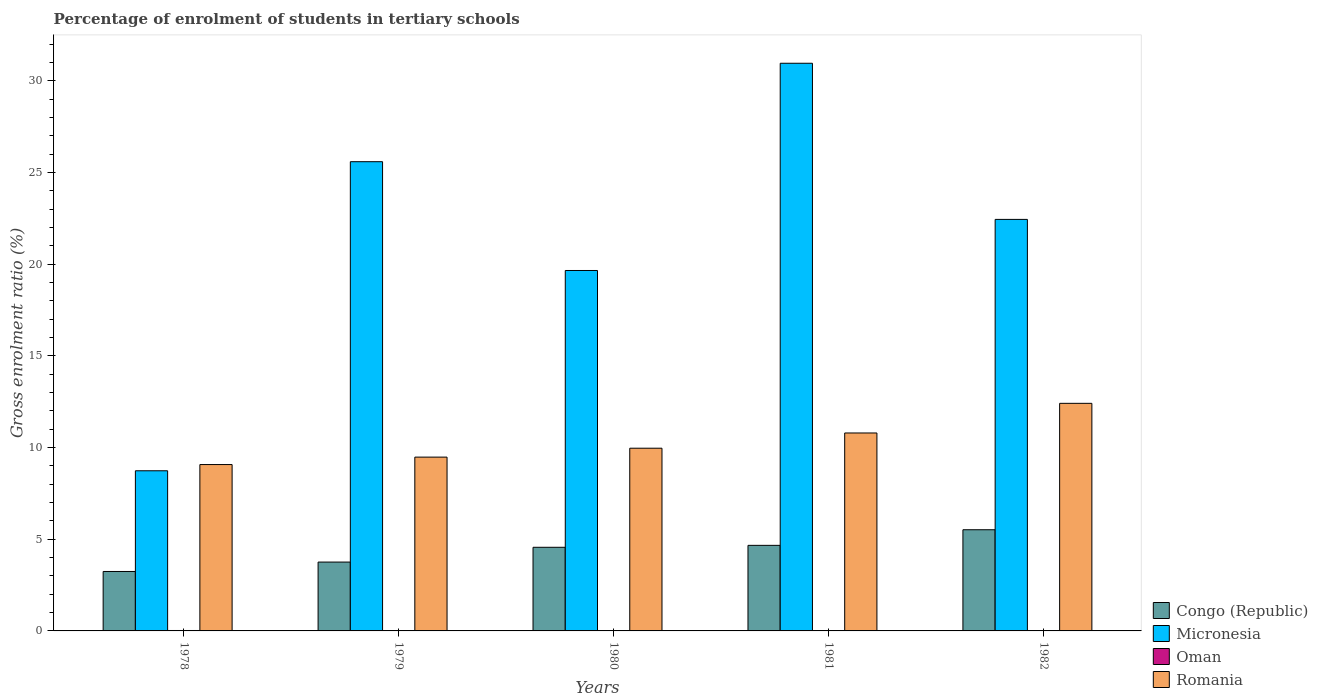Are the number of bars on each tick of the X-axis equal?
Offer a terse response. Yes. How many bars are there on the 3rd tick from the left?
Offer a terse response. 4. What is the label of the 5th group of bars from the left?
Ensure brevity in your answer.  1982. In how many cases, is the number of bars for a given year not equal to the number of legend labels?
Your response must be concise. 0. What is the percentage of students enrolled in tertiary schools in Romania in 1978?
Your answer should be compact. 9.07. Across all years, what is the maximum percentage of students enrolled in tertiary schools in Romania?
Make the answer very short. 12.41. Across all years, what is the minimum percentage of students enrolled in tertiary schools in Romania?
Keep it short and to the point. 9.07. In which year was the percentage of students enrolled in tertiary schools in Micronesia minimum?
Your response must be concise. 1978. What is the total percentage of students enrolled in tertiary schools in Romania in the graph?
Give a very brief answer. 51.73. What is the difference between the percentage of students enrolled in tertiary schools in Congo (Republic) in 1978 and that in 1982?
Give a very brief answer. -2.28. What is the difference between the percentage of students enrolled in tertiary schools in Micronesia in 1979 and the percentage of students enrolled in tertiary schools in Oman in 1980?
Make the answer very short. 25.58. What is the average percentage of students enrolled in tertiary schools in Congo (Republic) per year?
Offer a terse response. 4.35. In the year 1981, what is the difference between the percentage of students enrolled in tertiary schools in Oman and percentage of students enrolled in tertiary schools in Romania?
Your answer should be very brief. -10.78. What is the ratio of the percentage of students enrolled in tertiary schools in Romania in 1981 to that in 1982?
Offer a very short reply. 0.87. What is the difference between the highest and the second highest percentage of students enrolled in tertiary schools in Micronesia?
Make the answer very short. 5.37. What is the difference between the highest and the lowest percentage of students enrolled in tertiary schools in Congo (Republic)?
Keep it short and to the point. 2.28. What does the 4th bar from the left in 1982 represents?
Ensure brevity in your answer.  Romania. What does the 4th bar from the right in 1982 represents?
Provide a succinct answer. Congo (Republic). Are all the bars in the graph horizontal?
Ensure brevity in your answer.  No. How many years are there in the graph?
Offer a terse response. 5. Are the values on the major ticks of Y-axis written in scientific E-notation?
Offer a very short reply. No. Does the graph contain any zero values?
Provide a succinct answer. No. Where does the legend appear in the graph?
Your answer should be very brief. Bottom right. How many legend labels are there?
Make the answer very short. 4. How are the legend labels stacked?
Keep it short and to the point. Vertical. What is the title of the graph?
Your answer should be very brief. Percentage of enrolment of students in tertiary schools. Does "Congo (Republic)" appear as one of the legend labels in the graph?
Offer a very short reply. Yes. What is the label or title of the X-axis?
Offer a terse response. Years. What is the Gross enrolment ratio (%) of Congo (Republic) in 1978?
Provide a short and direct response. 3.24. What is the Gross enrolment ratio (%) of Micronesia in 1978?
Keep it short and to the point. 8.73. What is the Gross enrolment ratio (%) in Oman in 1978?
Provide a succinct answer. 0.02. What is the Gross enrolment ratio (%) of Romania in 1978?
Offer a very short reply. 9.07. What is the Gross enrolment ratio (%) in Congo (Republic) in 1979?
Offer a very short reply. 3.76. What is the Gross enrolment ratio (%) of Micronesia in 1979?
Your answer should be very brief. 25.59. What is the Gross enrolment ratio (%) in Oman in 1979?
Your response must be concise. 0.01. What is the Gross enrolment ratio (%) of Romania in 1979?
Your answer should be very brief. 9.48. What is the Gross enrolment ratio (%) in Congo (Republic) in 1980?
Provide a short and direct response. 4.56. What is the Gross enrolment ratio (%) of Micronesia in 1980?
Your response must be concise. 19.66. What is the Gross enrolment ratio (%) of Oman in 1980?
Provide a succinct answer. 0.02. What is the Gross enrolment ratio (%) of Romania in 1980?
Your answer should be very brief. 9.97. What is the Gross enrolment ratio (%) of Congo (Republic) in 1981?
Make the answer very short. 4.67. What is the Gross enrolment ratio (%) in Micronesia in 1981?
Your response must be concise. 30.96. What is the Gross enrolment ratio (%) in Oman in 1981?
Keep it short and to the point. 0.02. What is the Gross enrolment ratio (%) of Romania in 1981?
Provide a short and direct response. 10.8. What is the Gross enrolment ratio (%) of Congo (Republic) in 1982?
Keep it short and to the point. 5.52. What is the Gross enrolment ratio (%) of Micronesia in 1982?
Your answer should be very brief. 22.45. What is the Gross enrolment ratio (%) in Oman in 1982?
Keep it short and to the point. 0.01. What is the Gross enrolment ratio (%) in Romania in 1982?
Your answer should be very brief. 12.41. Across all years, what is the maximum Gross enrolment ratio (%) in Congo (Republic)?
Provide a succinct answer. 5.52. Across all years, what is the maximum Gross enrolment ratio (%) of Micronesia?
Provide a succinct answer. 30.96. Across all years, what is the maximum Gross enrolment ratio (%) in Oman?
Ensure brevity in your answer.  0.02. Across all years, what is the maximum Gross enrolment ratio (%) in Romania?
Offer a very short reply. 12.41. Across all years, what is the minimum Gross enrolment ratio (%) of Congo (Republic)?
Your response must be concise. 3.24. Across all years, what is the minimum Gross enrolment ratio (%) of Micronesia?
Make the answer very short. 8.73. Across all years, what is the minimum Gross enrolment ratio (%) of Oman?
Your response must be concise. 0.01. Across all years, what is the minimum Gross enrolment ratio (%) of Romania?
Provide a short and direct response. 9.07. What is the total Gross enrolment ratio (%) of Congo (Republic) in the graph?
Provide a succinct answer. 21.74. What is the total Gross enrolment ratio (%) in Micronesia in the graph?
Provide a short and direct response. 107.4. What is the total Gross enrolment ratio (%) of Oman in the graph?
Your answer should be very brief. 0.09. What is the total Gross enrolment ratio (%) in Romania in the graph?
Keep it short and to the point. 51.73. What is the difference between the Gross enrolment ratio (%) in Congo (Republic) in 1978 and that in 1979?
Make the answer very short. -0.51. What is the difference between the Gross enrolment ratio (%) in Micronesia in 1978 and that in 1979?
Offer a very short reply. -16.86. What is the difference between the Gross enrolment ratio (%) in Oman in 1978 and that in 1979?
Your response must be concise. 0.01. What is the difference between the Gross enrolment ratio (%) of Romania in 1978 and that in 1979?
Offer a terse response. -0.41. What is the difference between the Gross enrolment ratio (%) in Congo (Republic) in 1978 and that in 1980?
Offer a terse response. -1.32. What is the difference between the Gross enrolment ratio (%) of Micronesia in 1978 and that in 1980?
Your response must be concise. -10.93. What is the difference between the Gross enrolment ratio (%) of Oman in 1978 and that in 1980?
Provide a short and direct response. 0.01. What is the difference between the Gross enrolment ratio (%) of Romania in 1978 and that in 1980?
Provide a short and direct response. -0.89. What is the difference between the Gross enrolment ratio (%) in Congo (Republic) in 1978 and that in 1981?
Provide a succinct answer. -1.42. What is the difference between the Gross enrolment ratio (%) of Micronesia in 1978 and that in 1981?
Your answer should be very brief. -22.23. What is the difference between the Gross enrolment ratio (%) of Oman in 1978 and that in 1981?
Make the answer very short. 0.01. What is the difference between the Gross enrolment ratio (%) in Romania in 1978 and that in 1981?
Offer a very short reply. -1.72. What is the difference between the Gross enrolment ratio (%) in Congo (Republic) in 1978 and that in 1982?
Ensure brevity in your answer.  -2.28. What is the difference between the Gross enrolment ratio (%) of Micronesia in 1978 and that in 1982?
Provide a succinct answer. -13.71. What is the difference between the Gross enrolment ratio (%) of Oman in 1978 and that in 1982?
Offer a very short reply. 0.01. What is the difference between the Gross enrolment ratio (%) in Romania in 1978 and that in 1982?
Keep it short and to the point. -3.34. What is the difference between the Gross enrolment ratio (%) of Congo (Republic) in 1979 and that in 1980?
Ensure brevity in your answer.  -0.81. What is the difference between the Gross enrolment ratio (%) in Micronesia in 1979 and that in 1980?
Offer a terse response. 5.93. What is the difference between the Gross enrolment ratio (%) in Oman in 1979 and that in 1980?
Provide a succinct answer. -0. What is the difference between the Gross enrolment ratio (%) in Romania in 1979 and that in 1980?
Make the answer very short. -0.49. What is the difference between the Gross enrolment ratio (%) of Congo (Republic) in 1979 and that in 1981?
Provide a short and direct response. -0.91. What is the difference between the Gross enrolment ratio (%) in Micronesia in 1979 and that in 1981?
Make the answer very short. -5.37. What is the difference between the Gross enrolment ratio (%) in Oman in 1979 and that in 1981?
Keep it short and to the point. -0. What is the difference between the Gross enrolment ratio (%) of Romania in 1979 and that in 1981?
Give a very brief answer. -1.32. What is the difference between the Gross enrolment ratio (%) of Congo (Republic) in 1979 and that in 1982?
Give a very brief answer. -1.76. What is the difference between the Gross enrolment ratio (%) of Micronesia in 1979 and that in 1982?
Make the answer very short. 3.15. What is the difference between the Gross enrolment ratio (%) in Oman in 1979 and that in 1982?
Your answer should be very brief. 0. What is the difference between the Gross enrolment ratio (%) of Romania in 1979 and that in 1982?
Your response must be concise. -2.93. What is the difference between the Gross enrolment ratio (%) in Congo (Republic) in 1980 and that in 1981?
Offer a very short reply. -0.11. What is the difference between the Gross enrolment ratio (%) of Micronesia in 1980 and that in 1981?
Your answer should be very brief. -11.3. What is the difference between the Gross enrolment ratio (%) of Oman in 1980 and that in 1981?
Make the answer very short. -0. What is the difference between the Gross enrolment ratio (%) of Romania in 1980 and that in 1981?
Offer a terse response. -0.83. What is the difference between the Gross enrolment ratio (%) of Congo (Republic) in 1980 and that in 1982?
Your answer should be very brief. -0.96. What is the difference between the Gross enrolment ratio (%) in Micronesia in 1980 and that in 1982?
Your answer should be compact. -2.79. What is the difference between the Gross enrolment ratio (%) of Oman in 1980 and that in 1982?
Your answer should be very brief. 0. What is the difference between the Gross enrolment ratio (%) in Romania in 1980 and that in 1982?
Keep it short and to the point. -2.45. What is the difference between the Gross enrolment ratio (%) of Congo (Republic) in 1981 and that in 1982?
Ensure brevity in your answer.  -0.85. What is the difference between the Gross enrolment ratio (%) in Micronesia in 1981 and that in 1982?
Your response must be concise. 8.52. What is the difference between the Gross enrolment ratio (%) of Oman in 1981 and that in 1982?
Your answer should be compact. 0. What is the difference between the Gross enrolment ratio (%) of Romania in 1981 and that in 1982?
Offer a very short reply. -1.62. What is the difference between the Gross enrolment ratio (%) in Congo (Republic) in 1978 and the Gross enrolment ratio (%) in Micronesia in 1979?
Ensure brevity in your answer.  -22.35. What is the difference between the Gross enrolment ratio (%) of Congo (Republic) in 1978 and the Gross enrolment ratio (%) of Oman in 1979?
Make the answer very short. 3.23. What is the difference between the Gross enrolment ratio (%) of Congo (Republic) in 1978 and the Gross enrolment ratio (%) of Romania in 1979?
Your response must be concise. -6.24. What is the difference between the Gross enrolment ratio (%) of Micronesia in 1978 and the Gross enrolment ratio (%) of Oman in 1979?
Offer a very short reply. 8.72. What is the difference between the Gross enrolment ratio (%) in Micronesia in 1978 and the Gross enrolment ratio (%) in Romania in 1979?
Your response must be concise. -0.74. What is the difference between the Gross enrolment ratio (%) of Oman in 1978 and the Gross enrolment ratio (%) of Romania in 1979?
Ensure brevity in your answer.  -9.46. What is the difference between the Gross enrolment ratio (%) of Congo (Republic) in 1978 and the Gross enrolment ratio (%) of Micronesia in 1980?
Your response must be concise. -16.42. What is the difference between the Gross enrolment ratio (%) in Congo (Republic) in 1978 and the Gross enrolment ratio (%) in Oman in 1980?
Offer a terse response. 3.23. What is the difference between the Gross enrolment ratio (%) of Congo (Republic) in 1978 and the Gross enrolment ratio (%) of Romania in 1980?
Provide a succinct answer. -6.72. What is the difference between the Gross enrolment ratio (%) in Micronesia in 1978 and the Gross enrolment ratio (%) in Oman in 1980?
Your answer should be compact. 8.72. What is the difference between the Gross enrolment ratio (%) of Micronesia in 1978 and the Gross enrolment ratio (%) of Romania in 1980?
Your answer should be compact. -1.23. What is the difference between the Gross enrolment ratio (%) in Oman in 1978 and the Gross enrolment ratio (%) in Romania in 1980?
Keep it short and to the point. -9.94. What is the difference between the Gross enrolment ratio (%) of Congo (Republic) in 1978 and the Gross enrolment ratio (%) of Micronesia in 1981?
Your answer should be compact. -27.72. What is the difference between the Gross enrolment ratio (%) of Congo (Republic) in 1978 and the Gross enrolment ratio (%) of Oman in 1981?
Your answer should be very brief. 3.22. What is the difference between the Gross enrolment ratio (%) in Congo (Republic) in 1978 and the Gross enrolment ratio (%) in Romania in 1981?
Provide a succinct answer. -7.55. What is the difference between the Gross enrolment ratio (%) in Micronesia in 1978 and the Gross enrolment ratio (%) in Oman in 1981?
Ensure brevity in your answer.  8.72. What is the difference between the Gross enrolment ratio (%) of Micronesia in 1978 and the Gross enrolment ratio (%) of Romania in 1981?
Your answer should be very brief. -2.06. What is the difference between the Gross enrolment ratio (%) in Oman in 1978 and the Gross enrolment ratio (%) in Romania in 1981?
Your answer should be very brief. -10.77. What is the difference between the Gross enrolment ratio (%) of Congo (Republic) in 1978 and the Gross enrolment ratio (%) of Micronesia in 1982?
Your answer should be very brief. -19.2. What is the difference between the Gross enrolment ratio (%) in Congo (Republic) in 1978 and the Gross enrolment ratio (%) in Oman in 1982?
Offer a very short reply. 3.23. What is the difference between the Gross enrolment ratio (%) in Congo (Republic) in 1978 and the Gross enrolment ratio (%) in Romania in 1982?
Offer a terse response. -9.17. What is the difference between the Gross enrolment ratio (%) of Micronesia in 1978 and the Gross enrolment ratio (%) of Oman in 1982?
Keep it short and to the point. 8.72. What is the difference between the Gross enrolment ratio (%) in Micronesia in 1978 and the Gross enrolment ratio (%) in Romania in 1982?
Offer a terse response. -3.68. What is the difference between the Gross enrolment ratio (%) in Oman in 1978 and the Gross enrolment ratio (%) in Romania in 1982?
Give a very brief answer. -12.39. What is the difference between the Gross enrolment ratio (%) in Congo (Republic) in 1979 and the Gross enrolment ratio (%) in Micronesia in 1980?
Your response must be concise. -15.9. What is the difference between the Gross enrolment ratio (%) in Congo (Republic) in 1979 and the Gross enrolment ratio (%) in Oman in 1980?
Make the answer very short. 3.74. What is the difference between the Gross enrolment ratio (%) of Congo (Republic) in 1979 and the Gross enrolment ratio (%) of Romania in 1980?
Your answer should be compact. -6.21. What is the difference between the Gross enrolment ratio (%) in Micronesia in 1979 and the Gross enrolment ratio (%) in Oman in 1980?
Offer a terse response. 25.58. What is the difference between the Gross enrolment ratio (%) in Micronesia in 1979 and the Gross enrolment ratio (%) in Romania in 1980?
Provide a short and direct response. 15.63. What is the difference between the Gross enrolment ratio (%) of Oman in 1979 and the Gross enrolment ratio (%) of Romania in 1980?
Offer a very short reply. -9.95. What is the difference between the Gross enrolment ratio (%) in Congo (Republic) in 1979 and the Gross enrolment ratio (%) in Micronesia in 1981?
Make the answer very short. -27.21. What is the difference between the Gross enrolment ratio (%) in Congo (Republic) in 1979 and the Gross enrolment ratio (%) in Oman in 1981?
Your answer should be very brief. 3.74. What is the difference between the Gross enrolment ratio (%) of Congo (Republic) in 1979 and the Gross enrolment ratio (%) of Romania in 1981?
Provide a succinct answer. -7.04. What is the difference between the Gross enrolment ratio (%) in Micronesia in 1979 and the Gross enrolment ratio (%) in Oman in 1981?
Your answer should be compact. 25.58. What is the difference between the Gross enrolment ratio (%) in Micronesia in 1979 and the Gross enrolment ratio (%) in Romania in 1981?
Offer a terse response. 14.8. What is the difference between the Gross enrolment ratio (%) in Oman in 1979 and the Gross enrolment ratio (%) in Romania in 1981?
Your response must be concise. -10.78. What is the difference between the Gross enrolment ratio (%) in Congo (Republic) in 1979 and the Gross enrolment ratio (%) in Micronesia in 1982?
Offer a terse response. -18.69. What is the difference between the Gross enrolment ratio (%) in Congo (Republic) in 1979 and the Gross enrolment ratio (%) in Oman in 1982?
Your answer should be compact. 3.74. What is the difference between the Gross enrolment ratio (%) in Congo (Republic) in 1979 and the Gross enrolment ratio (%) in Romania in 1982?
Your response must be concise. -8.66. What is the difference between the Gross enrolment ratio (%) of Micronesia in 1979 and the Gross enrolment ratio (%) of Oman in 1982?
Your response must be concise. 25.58. What is the difference between the Gross enrolment ratio (%) of Micronesia in 1979 and the Gross enrolment ratio (%) of Romania in 1982?
Offer a very short reply. 13.18. What is the difference between the Gross enrolment ratio (%) of Oman in 1979 and the Gross enrolment ratio (%) of Romania in 1982?
Your answer should be very brief. -12.4. What is the difference between the Gross enrolment ratio (%) of Congo (Republic) in 1980 and the Gross enrolment ratio (%) of Micronesia in 1981?
Provide a succinct answer. -26.4. What is the difference between the Gross enrolment ratio (%) of Congo (Republic) in 1980 and the Gross enrolment ratio (%) of Oman in 1981?
Offer a very short reply. 4.54. What is the difference between the Gross enrolment ratio (%) in Congo (Republic) in 1980 and the Gross enrolment ratio (%) in Romania in 1981?
Offer a very short reply. -6.23. What is the difference between the Gross enrolment ratio (%) of Micronesia in 1980 and the Gross enrolment ratio (%) of Oman in 1981?
Keep it short and to the point. 19.64. What is the difference between the Gross enrolment ratio (%) in Micronesia in 1980 and the Gross enrolment ratio (%) in Romania in 1981?
Make the answer very short. 8.86. What is the difference between the Gross enrolment ratio (%) in Oman in 1980 and the Gross enrolment ratio (%) in Romania in 1981?
Provide a short and direct response. -10.78. What is the difference between the Gross enrolment ratio (%) in Congo (Republic) in 1980 and the Gross enrolment ratio (%) in Micronesia in 1982?
Offer a terse response. -17.88. What is the difference between the Gross enrolment ratio (%) in Congo (Republic) in 1980 and the Gross enrolment ratio (%) in Oman in 1982?
Your response must be concise. 4.55. What is the difference between the Gross enrolment ratio (%) of Congo (Republic) in 1980 and the Gross enrolment ratio (%) of Romania in 1982?
Offer a very short reply. -7.85. What is the difference between the Gross enrolment ratio (%) of Micronesia in 1980 and the Gross enrolment ratio (%) of Oman in 1982?
Offer a very short reply. 19.65. What is the difference between the Gross enrolment ratio (%) in Micronesia in 1980 and the Gross enrolment ratio (%) in Romania in 1982?
Your answer should be compact. 7.25. What is the difference between the Gross enrolment ratio (%) of Oman in 1980 and the Gross enrolment ratio (%) of Romania in 1982?
Keep it short and to the point. -12.4. What is the difference between the Gross enrolment ratio (%) of Congo (Republic) in 1981 and the Gross enrolment ratio (%) of Micronesia in 1982?
Provide a succinct answer. -17.78. What is the difference between the Gross enrolment ratio (%) in Congo (Republic) in 1981 and the Gross enrolment ratio (%) in Oman in 1982?
Provide a short and direct response. 4.65. What is the difference between the Gross enrolment ratio (%) of Congo (Republic) in 1981 and the Gross enrolment ratio (%) of Romania in 1982?
Provide a succinct answer. -7.75. What is the difference between the Gross enrolment ratio (%) of Micronesia in 1981 and the Gross enrolment ratio (%) of Oman in 1982?
Provide a short and direct response. 30.95. What is the difference between the Gross enrolment ratio (%) of Micronesia in 1981 and the Gross enrolment ratio (%) of Romania in 1982?
Keep it short and to the point. 18.55. What is the difference between the Gross enrolment ratio (%) of Oman in 1981 and the Gross enrolment ratio (%) of Romania in 1982?
Offer a terse response. -12.4. What is the average Gross enrolment ratio (%) of Congo (Republic) per year?
Offer a very short reply. 4.35. What is the average Gross enrolment ratio (%) of Micronesia per year?
Offer a very short reply. 21.48. What is the average Gross enrolment ratio (%) in Oman per year?
Your answer should be very brief. 0.02. What is the average Gross enrolment ratio (%) of Romania per year?
Ensure brevity in your answer.  10.35. In the year 1978, what is the difference between the Gross enrolment ratio (%) in Congo (Republic) and Gross enrolment ratio (%) in Micronesia?
Offer a very short reply. -5.49. In the year 1978, what is the difference between the Gross enrolment ratio (%) of Congo (Republic) and Gross enrolment ratio (%) of Oman?
Your answer should be compact. 3.22. In the year 1978, what is the difference between the Gross enrolment ratio (%) of Congo (Republic) and Gross enrolment ratio (%) of Romania?
Provide a succinct answer. -5.83. In the year 1978, what is the difference between the Gross enrolment ratio (%) in Micronesia and Gross enrolment ratio (%) in Oman?
Offer a terse response. 8.71. In the year 1978, what is the difference between the Gross enrolment ratio (%) in Micronesia and Gross enrolment ratio (%) in Romania?
Your response must be concise. -0.34. In the year 1978, what is the difference between the Gross enrolment ratio (%) in Oman and Gross enrolment ratio (%) in Romania?
Your answer should be compact. -9.05. In the year 1979, what is the difference between the Gross enrolment ratio (%) in Congo (Republic) and Gross enrolment ratio (%) in Micronesia?
Provide a succinct answer. -21.84. In the year 1979, what is the difference between the Gross enrolment ratio (%) of Congo (Republic) and Gross enrolment ratio (%) of Oman?
Your answer should be very brief. 3.74. In the year 1979, what is the difference between the Gross enrolment ratio (%) of Congo (Republic) and Gross enrolment ratio (%) of Romania?
Keep it short and to the point. -5.72. In the year 1979, what is the difference between the Gross enrolment ratio (%) of Micronesia and Gross enrolment ratio (%) of Oman?
Offer a terse response. 25.58. In the year 1979, what is the difference between the Gross enrolment ratio (%) in Micronesia and Gross enrolment ratio (%) in Romania?
Your response must be concise. 16.11. In the year 1979, what is the difference between the Gross enrolment ratio (%) of Oman and Gross enrolment ratio (%) of Romania?
Offer a terse response. -9.47. In the year 1980, what is the difference between the Gross enrolment ratio (%) of Congo (Republic) and Gross enrolment ratio (%) of Micronesia?
Ensure brevity in your answer.  -15.1. In the year 1980, what is the difference between the Gross enrolment ratio (%) in Congo (Republic) and Gross enrolment ratio (%) in Oman?
Your answer should be very brief. 4.55. In the year 1980, what is the difference between the Gross enrolment ratio (%) of Congo (Republic) and Gross enrolment ratio (%) of Romania?
Offer a terse response. -5.4. In the year 1980, what is the difference between the Gross enrolment ratio (%) in Micronesia and Gross enrolment ratio (%) in Oman?
Offer a terse response. 19.64. In the year 1980, what is the difference between the Gross enrolment ratio (%) in Micronesia and Gross enrolment ratio (%) in Romania?
Your answer should be very brief. 9.69. In the year 1980, what is the difference between the Gross enrolment ratio (%) of Oman and Gross enrolment ratio (%) of Romania?
Keep it short and to the point. -9.95. In the year 1981, what is the difference between the Gross enrolment ratio (%) of Congo (Republic) and Gross enrolment ratio (%) of Micronesia?
Give a very brief answer. -26.3. In the year 1981, what is the difference between the Gross enrolment ratio (%) in Congo (Republic) and Gross enrolment ratio (%) in Oman?
Give a very brief answer. 4.65. In the year 1981, what is the difference between the Gross enrolment ratio (%) of Congo (Republic) and Gross enrolment ratio (%) of Romania?
Your answer should be compact. -6.13. In the year 1981, what is the difference between the Gross enrolment ratio (%) of Micronesia and Gross enrolment ratio (%) of Oman?
Give a very brief answer. 30.94. In the year 1981, what is the difference between the Gross enrolment ratio (%) in Micronesia and Gross enrolment ratio (%) in Romania?
Provide a succinct answer. 20.17. In the year 1981, what is the difference between the Gross enrolment ratio (%) of Oman and Gross enrolment ratio (%) of Romania?
Your response must be concise. -10.78. In the year 1982, what is the difference between the Gross enrolment ratio (%) in Congo (Republic) and Gross enrolment ratio (%) in Micronesia?
Keep it short and to the point. -16.93. In the year 1982, what is the difference between the Gross enrolment ratio (%) in Congo (Republic) and Gross enrolment ratio (%) in Oman?
Give a very brief answer. 5.51. In the year 1982, what is the difference between the Gross enrolment ratio (%) of Congo (Republic) and Gross enrolment ratio (%) of Romania?
Your answer should be very brief. -6.9. In the year 1982, what is the difference between the Gross enrolment ratio (%) in Micronesia and Gross enrolment ratio (%) in Oman?
Give a very brief answer. 22.43. In the year 1982, what is the difference between the Gross enrolment ratio (%) in Micronesia and Gross enrolment ratio (%) in Romania?
Offer a terse response. 10.03. In the year 1982, what is the difference between the Gross enrolment ratio (%) of Oman and Gross enrolment ratio (%) of Romania?
Your answer should be compact. -12.4. What is the ratio of the Gross enrolment ratio (%) in Congo (Republic) in 1978 to that in 1979?
Provide a succinct answer. 0.86. What is the ratio of the Gross enrolment ratio (%) in Micronesia in 1978 to that in 1979?
Provide a succinct answer. 0.34. What is the ratio of the Gross enrolment ratio (%) of Oman in 1978 to that in 1979?
Give a very brief answer. 1.69. What is the ratio of the Gross enrolment ratio (%) in Romania in 1978 to that in 1979?
Offer a very short reply. 0.96. What is the ratio of the Gross enrolment ratio (%) of Congo (Republic) in 1978 to that in 1980?
Your response must be concise. 0.71. What is the ratio of the Gross enrolment ratio (%) in Micronesia in 1978 to that in 1980?
Offer a terse response. 0.44. What is the ratio of the Gross enrolment ratio (%) of Oman in 1978 to that in 1980?
Offer a terse response. 1.52. What is the ratio of the Gross enrolment ratio (%) of Romania in 1978 to that in 1980?
Your answer should be very brief. 0.91. What is the ratio of the Gross enrolment ratio (%) in Congo (Republic) in 1978 to that in 1981?
Make the answer very short. 0.69. What is the ratio of the Gross enrolment ratio (%) of Micronesia in 1978 to that in 1981?
Provide a succinct answer. 0.28. What is the ratio of the Gross enrolment ratio (%) in Oman in 1978 to that in 1981?
Offer a very short reply. 1.31. What is the ratio of the Gross enrolment ratio (%) in Romania in 1978 to that in 1981?
Keep it short and to the point. 0.84. What is the ratio of the Gross enrolment ratio (%) of Congo (Republic) in 1978 to that in 1982?
Your answer should be very brief. 0.59. What is the ratio of the Gross enrolment ratio (%) of Micronesia in 1978 to that in 1982?
Keep it short and to the point. 0.39. What is the ratio of the Gross enrolment ratio (%) in Oman in 1978 to that in 1982?
Provide a short and direct response. 1.78. What is the ratio of the Gross enrolment ratio (%) in Romania in 1978 to that in 1982?
Keep it short and to the point. 0.73. What is the ratio of the Gross enrolment ratio (%) of Congo (Republic) in 1979 to that in 1980?
Make the answer very short. 0.82. What is the ratio of the Gross enrolment ratio (%) of Micronesia in 1979 to that in 1980?
Offer a terse response. 1.3. What is the ratio of the Gross enrolment ratio (%) in Oman in 1979 to that in 1980?
Your answer should be compact. 0.9. What is the ratio of the Gross enrolment ratio (%) in Romania in 1979 to that in 1980?
Your answer should be compact. 0.95. What is the ratio of the Gross enrolment ratio (%) in Congo (Republic) in 1979 to that in 1981?
Offer a terse response. 0.8. What is the ratio of the Gross enrolment ratio (%) in Micronesia in 1979 to that in 1981?
Offer a very short reply. 0.83. What is the ratio of the Gross enrolment ratio (%) in Oman in 1979 to that in 1981?
Offer a terse response. 0.78. What is the ratio of the Gross enrolment ratio (%) of Romania in 1979 to that in 1981?
Provide a succinct answer. 0.88. What is the ratio of the Gross enrolment ratio (%) of Congo (Republic) in 1979 to that in 1982?
Make the answer very short. 0.68. What is the ratio of the Gross enrolment ratio (%) in Micronesia in 1979 to that in 1982?
Provide a succinct answer. 1.14. What is the ratio of the Gross enrolment ratio (%) of Oman in 1979 to that in 1982?
Your answer should be compact. 1.05. What is the ratio of the Gross enrolment ratio (%) of Romania in 1979 to that in 1982?
Provide a short and direct response. 0.76. What is the ratio of the Gross enrolment ratio (%) of Congo (Republic) in 1980 to that in 1981?
Offer a very short reply. 0.98. What is the ratio of the Gross enrolment ratio (%) in Micronesia in 1980 to that in 1981?
Provide a succinct answer. 0.63. What is the ratio of the Gross enrolment ratio (%) in Oman in 1980 to that in 1981?
Provide a succinct answer. 0.87. What is the ratio of the Gross enrolment ratio (%) of Romania in 1980 to that in 1981?
Provide a succinct answer. 0.92. What is the ratio of the Gross enrolment ratio (%) of Congo (Republic) in 1980 to that in 1982?
Provide a short and direct response. 0.83. What is the ratio of the Gross enrolment ratio (%) in Micronesia in 1980 to that in 1982?
Ensure brevity in your answer.  0.88. What is the ratio of the Gross enrolment ratio (%) of Oman in 1980 to that in 1982?
Your answer should be very brief. 1.17. What is the ratio of the Gross enrolment ratio (%) of Romania in 1980 to that in 1982?
Offer a terse response. 0.8. What is the ratio of the Gross enrolment ratio (%) of Congo (Republic) in 1981 to that in 1982?
Your answer should be compact. 0.85. What is the ratio of the Gross enrolment ratio (%) in Micronesia in 1981 to that in 1982?
Keep it short and to the point. 1.38. What is the ratio of the Gross enrolment ratio (%) in Oman in 1981 to that in 1982?
Ensure brevity in your answer.  1.35. What is the ratio of the Gross enrolment ratio (%) in Romania in 1981 to that in 1982?
Offer a very short reply. 0.87. What is the difference between the highest and the second highest Gross enrolment ratio (%) of Congo (Republic)?
Offer a very short reply. 0.85. What is the difference between the highest and the second highest Gross enrolment ratio (%) in Micronesia?
Your answer should be compact. 5.37. What is the difference between the highest and the second highest Gross enrolment ratio (%) of Oman?
Your answer should be compact. 0.01. What is the difference between the highest and the second highest Gross enrolment ratio (%) of Romania?
Offer a terse response. 1.62. What is the difference between the highest and the lowest Gross enrolment ratio (%) in Congo (Republic)?
Your response must be concise. 2.28. What is the difference between the highest and the lowest Gross enrolment ratio (%) in Micronesia?
Keep it short and to the point. 22.23. What is the difference between the highest and the lowest Gross enrolment ratio (%) in Oman?
Give a very brief answer. 0.01. What is the difference between the highest and the lowest Gross enrolment ratio (%) of Romania?
Your answer should be very brief. 3.34. 